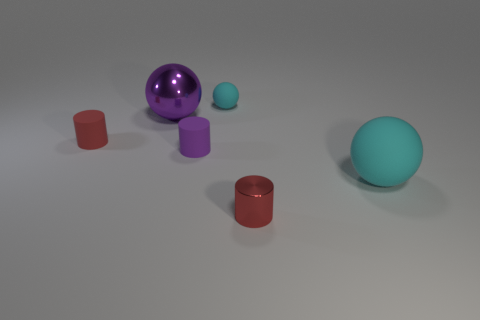Subtract all rubber cylinders. How many cylinders are left? 1 Subtract 1 cylinders. How many cylinders are left? 2 Add 4 tiny yellow rubber blocks. How many objects exist? 10 Subtract all yellow balls. Subtract all cyan cubes. How many balls are left? 3 Subtract all small brown things. Subtract all cyan rubber things. How many objects are left? 4 Add 2 small cyan matte objects. How many small cyan matte objects are left? 3 Add 6 blue shiny cylinders. How many blue shiny cylinders exist? 6 Subtract 0 blue cubes. How many objects are left? 6 